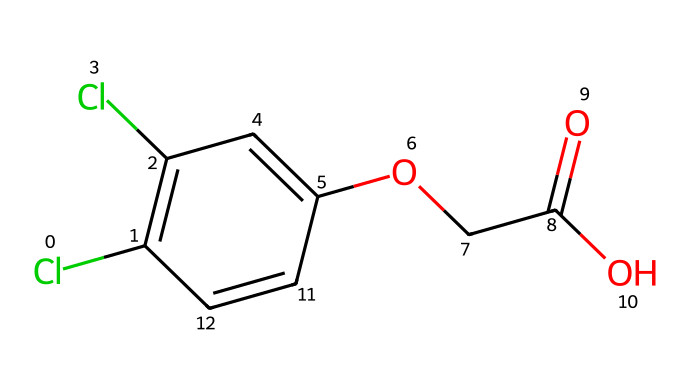What is the total number of chlorine atoms in the structure? By analyzing the SMILES representation, "Cl" appears twice, indicating there are two chlorine atoms present in the compound.
Answer: two How many carbon atoms are in 2,4-Dichlorophenoxyacetic acid? The molecular structure shows various carbon atoms throughout the representation. Counting all carbon parts reveals a total of 10 carbon atoms present in the structure.
Answer: ten What functional group can be identified in 2,4-Dichlorophenoxyacetic acid? Looking at the structure, the presence of "-OCC(=O)O" suggests a carboxylic acid functional group, which is typically characterized by the presence of –COOH.
Answer: carboxylic acid Which part of this herbicide's structure is responsible for its herbicidal activity? The aromatic ring and attached substituents (especially the dichlorophenyl group) play a significant role in its herbicidal properties by interfering with plant growth regulation.
Answer: dichlorophenyl group What is the general chemical type of 2,4-Dichlorophenoxyacetic acid? 2,4-D is commonly classified as a phenoxy herbicide, as it contains a phenoxy group which is characteristic of this type of herbicide.
Answer: phenoxy herbicide How many oxygen atoms are present in this molecule? Examining the structure reveals there are three oxygen atoms present, one in the carboxylic acid and two in the ether and carbonyl groups.
Answer: three What molecular feature distinguishes this herbicide as a selective herbicide? The structure's specific arrangement, including the presence of the two chlorine atoms and the ether linkage, allows it to selectively control broadleaf weeds while being less harmful to grasses.
Answer: selective control mechanism 